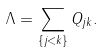<formula> <loc_0><loc_0><loc_500><loc_500>\Lambda = \sum _ { \{ j < k \} } Q _ { j k } .</formula> 